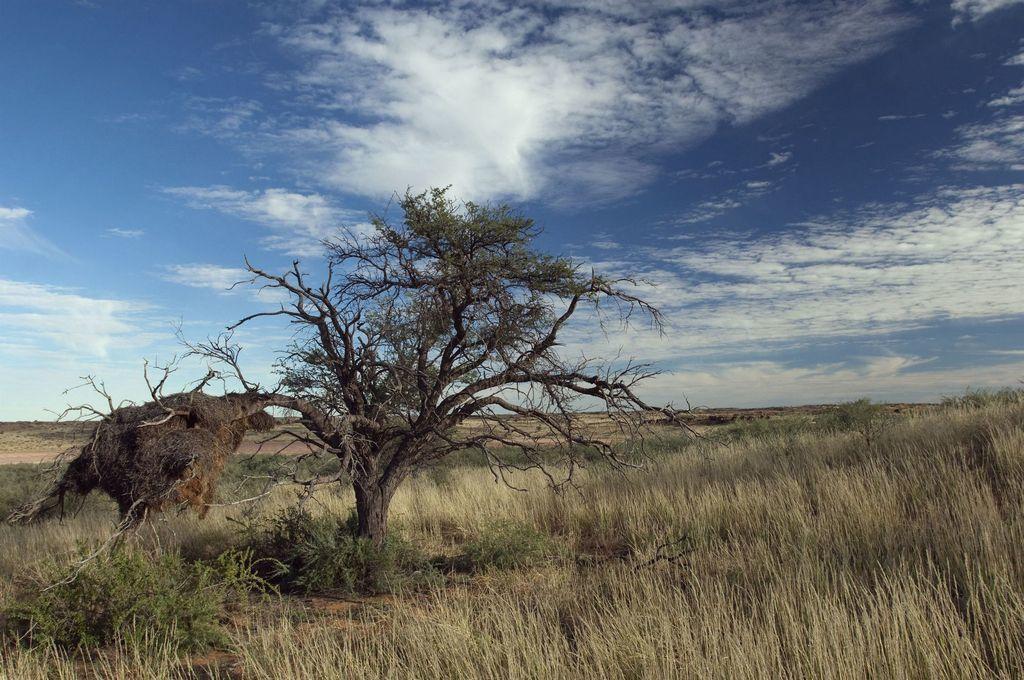Please provide a concise description of this image. It's a tree in the middle of an image. In the down side, it's grass, at the top it's a sunny sky. 